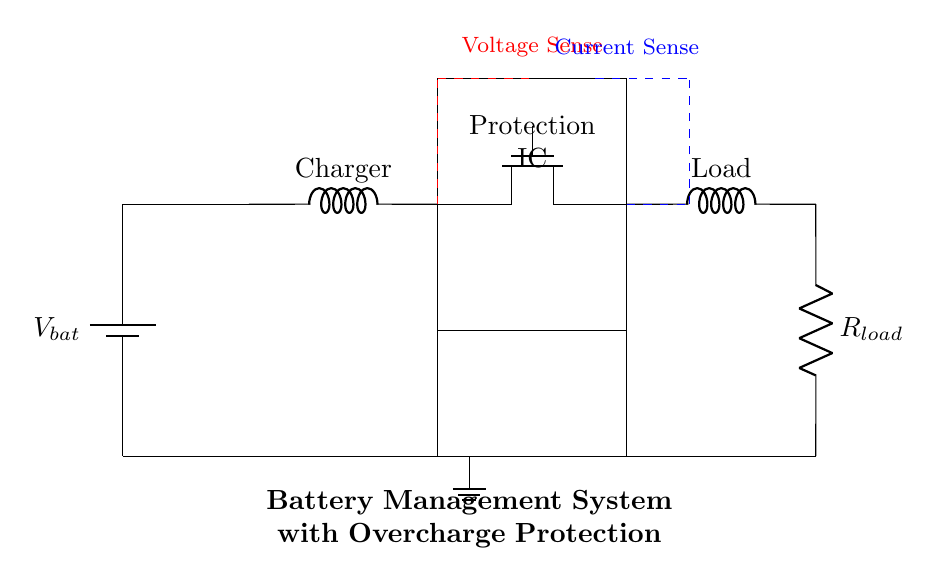What component regulates the charging process? The component that regulates the charging process is the Protection IC. It monitors the voltage and current to prevent overcharging.
Answer: Protection IC What type of MOSFET is used in this circuit? The type of MOSFET used in this circuit is a N-channel MOSFET, which typically allows higher current flow when a positive voltage is applied to its gate.
Answer: N-channel MOSFET What is the basic function of the voltage sense in this circuit? The voltage sense function is to monitor the voltage level of the battery to ensure it does not exceed the safe charging threshold, preventing overcharge.
Answer: To monitor battery voltage How does the current sensing mechanism contribute to the overcharge protection? The current sensing mechanism detects if the current exceeds a safe limit during charging. If it does, the Protection IC will disable the charging MOSFET, preventing overcharging.
Answer: It detects excess current What happens when the battery voltage exceeds the preset limit? When the battery voltage exceeds the preset limit, the Protection IC will disable the charging MOSFET, stopping the charging process to avoid damage from overcharging.
Answer: Charging is disabled What is the role of the charging circuit in this battery management system? The role of the charging circuit is to provide a regulated flow of current to charge the battery safely, while the protection features help prevent overcharging.
Answer: To provide regulated charging 